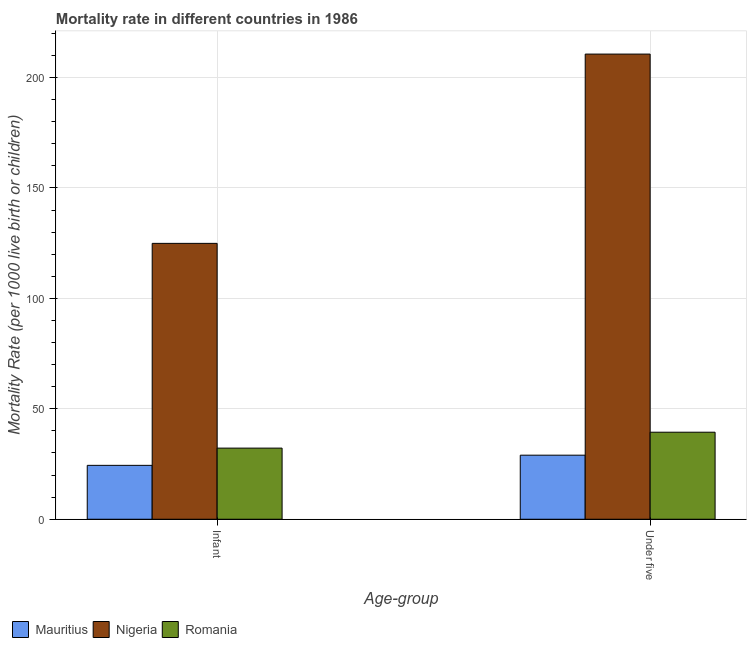How many groups of bars are there?
Offer a very short reply. 2. What is the label of the 1st group of bars from the left?
Make the answer very short. Infant. What is the under-5 mortality rate in Romania?
Your answer should be compact. 39.4. Across all countries, what is the maximum under-5 mortality rate?
Offer a terse response. 210.6. In which country was the infant mortality rate maximum?
Keep it short and to the point. Nigeria. In which country was the under-5 mortality rate minimum?
Provide a short and direct response. Mauritius. What is the total infant mortality rate in the graph?
Provide a succinct answer. 181.5. What is the difference between the infant mortality rate in Nigeria and that in Romania?
Your answer should be compact. 92.7. What is the difference between the under-5 mortality rate in Mauritius and the infant mortality rate in Romania?
Your answer should be compact. -3.2. What is the average infant mortality rate per country?
Offer a very short reply. 60.5. What is the difference between the under-5 mortality rate and infant mortality rate in Nigeria?
Make the answer very short. 85.7. What is the ratio of the under-5 mortality rate in Romania to that in Mauritius?
Ensure brevity in your answer.  1.36. Is the under-5 mortality rate in Mauritius less than that in Romania?
Offer a terse response. Yes. In how many countries, is the under-5 mortality rate greater than the average under-5 mortality rate taken over all countries?
Your response must be concise. 1. What does the 2nd bar from the left in Infant represents?
Your response must be concise. Nigeria. What does the 1st bar from the right in Infant represents?
Make the answer very short. Romania. How many bars are there?
Keep it short and to the point. 6. Are all the bars in the graph horizontal?
Keep it short and to the point. No. What is the difference between two consecutive major ticks on the Y-axis?
Provide a short and direct response. 50. Does the graph contain any zero values?
Give a very brief answer. No. Does the graph contain grids?
Keep it short and to the point. Yes. How many legend labels are there?
Keep it short and to the point. 3. How are the legend labels stacked?
Provide a succinct answer. Horizontal. What is the title of the graph?
Offer a terse response. Mortality rate in different countries in 1986. Does "World" appear as one of the legend labels in the graph?
Provide a succinct answer. No. What is the label or title of the X-axis?
Provide a succinct answer. Age-group. What is the label or title of the Y-axis?
Offer a terse response. Mortality Rate (per 1000 live birth or children). What is the Mortality Rate (per 1000 live birth or children) of Mauritius in Infant?
Your response must be concise. 24.4. What is the Mortality Rate (per 1000 live birth or children) of Nigeria in Infant?
Provide a succinct answer. 124.9. What is the Mortality Rate (per 1000 live birth or children) in Romania in Infant?
Offer a terse response. 32.2. What is the Mortality Rate (per 1000 live birth or children) of Nigeria in Under five?
Your answer should be compact. 210.6. What is the Mortality Rate (per 1000 live birth or children) of Romania in Under five?
Provide a succinct answer. 39.4. Across all Age-group, what is the maximum Mortality Rate (per 1000 live birth or children) in Mauritius?
Ensure brevity in your answer.  29. Across all Age-group, what is the maximum Mortality Rate (per 1000 live birth or children) of Nigeria?
Make the answer very short. 210.6. Across all Age-group, what is the maximum Mortality Rate (per 1000 live birth or children) in Romania?
Offer a very short reply. 39.4. Across all Age-group, what is the minimum Mortality Rate (per 1000 live birth or children) in Mauritius?
Provide a short and direct response. 24.4. Across all Age-group, what is the minimum Mortality Rate (per 1000 live birth or children) of Nigeria?
Your answer should be compact. 124.9. Across all Age-group, what is the minimum Mortality Rate (per 1000 live birth or children) in Romania?
Keep it short and to the point. 32.2. What is the total Mortality Rate (per 1000 live birth or children) in Mauritius in the graph?
Provide a succinct answer. 53.4. What is the total Mortality Rate (per 1000 live birth or children) of Nigeria in the graph?
Offer a terse response. 335.5. What is the total Mortality Rate (per 1000 live birth or children) in Romania in the graph?
Your answer should be very brief. 71.6. What is the difference between the Mortality Rate (per 1000 live birth or children) of Mauritius in Infant and that in Under five?
Ensure brevity in your answer.  -4.6. What is the difference between the Mortality Rate (per 1000 live birth or children) of Nigeria in Infant and that in Under five?
Provide a succinct answer. -85.7. What is the difference between the Mortality Rate (per 1000 live birth or children) of Romania in Infant and that in Under five?
Ensure brevity in your answer.  -7.2. What is the difference between the Mortality Rate (per 1000 live birth or children) in Mauritius in Infant and the Mortality Rate (per 1000 live birth or children) in Nigeria in Under five?
Offer a very short reply. -186.2. What is the difference between the Mortality Rate (per 1000 live birth or children) of Nigeria in Infant and the Mortality Rate (per 1000 live birth or children) of Romania in Under five?
Give a very brief answer. 85.5. What is the average Mortality Rate (per 1000 live birth or children) of Mauritius per Age-group?
Ensure brevity in your answer.  26.7. What is the average Mortality Rate (per 1000 live birth or children) of Nigeria per Age-group?
Keep it short and to the point. 167.75. What is the average Mortality Rate (per 1000 live birth or children) in Romania per Age-group?
Your answer should be compact. 35.8. What is the difference between the Mortality Rate (per 1000 live birth or children) of Mauritius and Mortality Rate (per 1000 live birth or children) of Nigeria in Infant?
Ensure brevity in your answer.  -100.5. What is the difference between the Mortality Rate (per 1000 live birth or children) in Mauritius and Mortality Rate (per 1000 live birth or children) in Romania in Infant?
Make the answer very short. -7.8. What is the difference between the Mortality Rate (per 1000 live birth or children) in Nigeria and Mortality Rate (per 1000 live birth or children) in Romania in Infant?
Provide a succinct answer. 92.7. What is the difference between the Mortality Rate (per 1000 live birth or children) in Mauritius and Mortality Rate (per 1000 live birth or children) in Nigeria in Under five?
Make the answer very short. -181.6. What is the difference between the Mortality Rate (per 1000 live birth or children) of Nigeria and Mortality Rate (per 1000 live birth or children) of Romania in Under five?
Your response must be concise. 171.2. What is the ratio of the Mortality Rate (per 1000 live birth or children) of Mauritius in Infant to that in Under five?
Your answer should be very brief. 0.84. What is the ratio of the Mortality Rate (per 1000 live birth or children) of Nigeria in Infant to that in Under five?
Ensure brevity in your answer.  0.59. What is the ratio of the Mortality Rate (per 1000 live birth or children) in Romania in Infant to that in Under five?
Keep it short and to the point. 0.82. What is the difference between the highest and the second highest Mortality Rate (per 1000 live birth or children) in Nigeria?
Give a very brief answer. 85.7. What is the difference between the highest and the second highest Mortality Rate (per 1000 live birth or children) in Romania?
Your response must be concise. 7.2. What is the difference between the highest and the lowest Mortality Rate (per 1000 live birth or children) in Nigeria?
Your answer should be very brief. 85.7. What is the difference between the highest and the lowest Mortality Rate (per 1000 live birth or children) of Romania?
Your response must be concise. 7.2. 